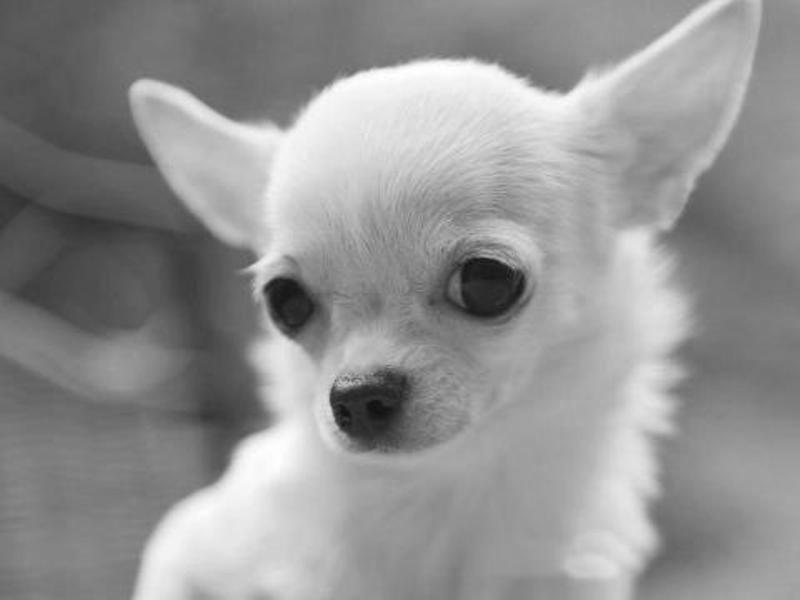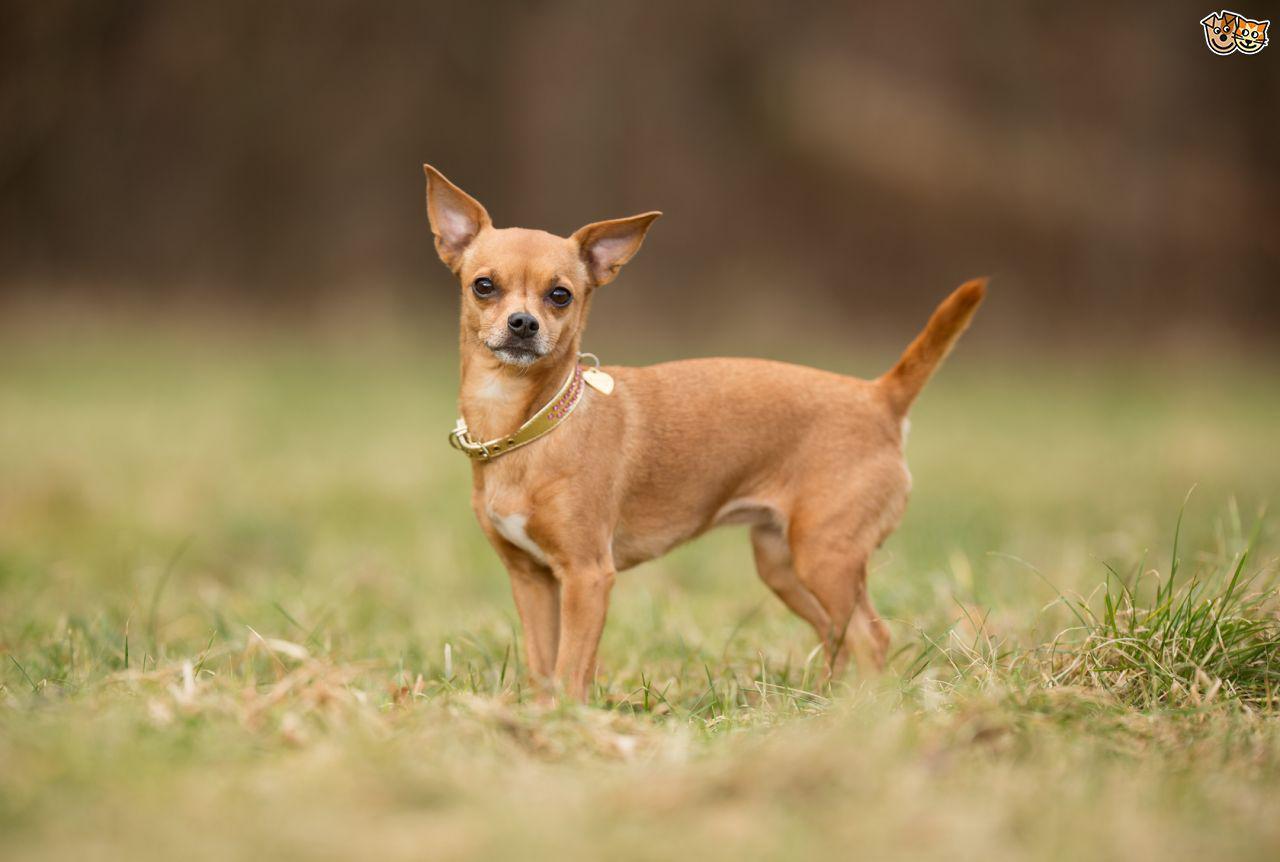The first image is the image on the left, the second image is the image on the right. Analyze the images presented: Is the assertion "At least one image shows a small dog standing on green grass." valid? Answer yes or no. Yes. 